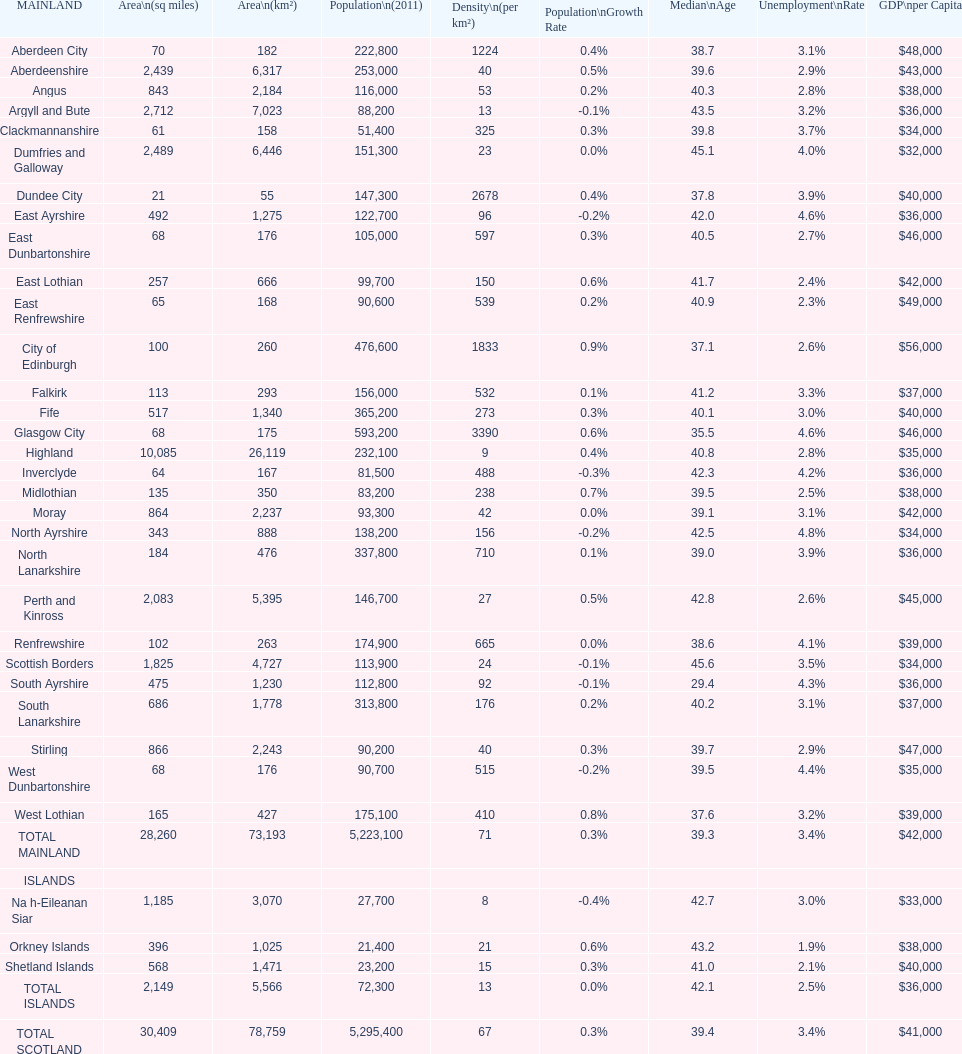What is the number of people living in angus in 2011? 116,000. 